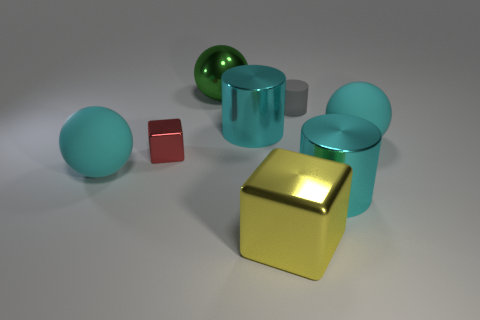Add 2 small brown matte cylinders. How many objects exist? 10 Subtract all spheres. How many objects are left? 5 Add 5 red metallic objects. How many red metallic objects are left? 6 Add 6 large gray shiny blocks. How many large gray shiny blocks exist? 6 Subtract 1 yellow blocks. How many objects are left? 7 Subtract all small gray cylinders. Subtract all small shiny blocks. How many objects are left? 6 